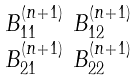Convert formula to latex. <formula><loc_0><loc_0><loc_500><loc_500>\begin{smallmatrix} B ^ { ( n + 1 ) } _ { 1 1 } & B ^ { ( n + 1 ) } _ { 1 2 } \\ B ^ { ( n + 1 ) } _ { 2 1 } & B ^ { ( n + 1 ) } _ { 2 2 } \end{smallmatrix}</formula> 